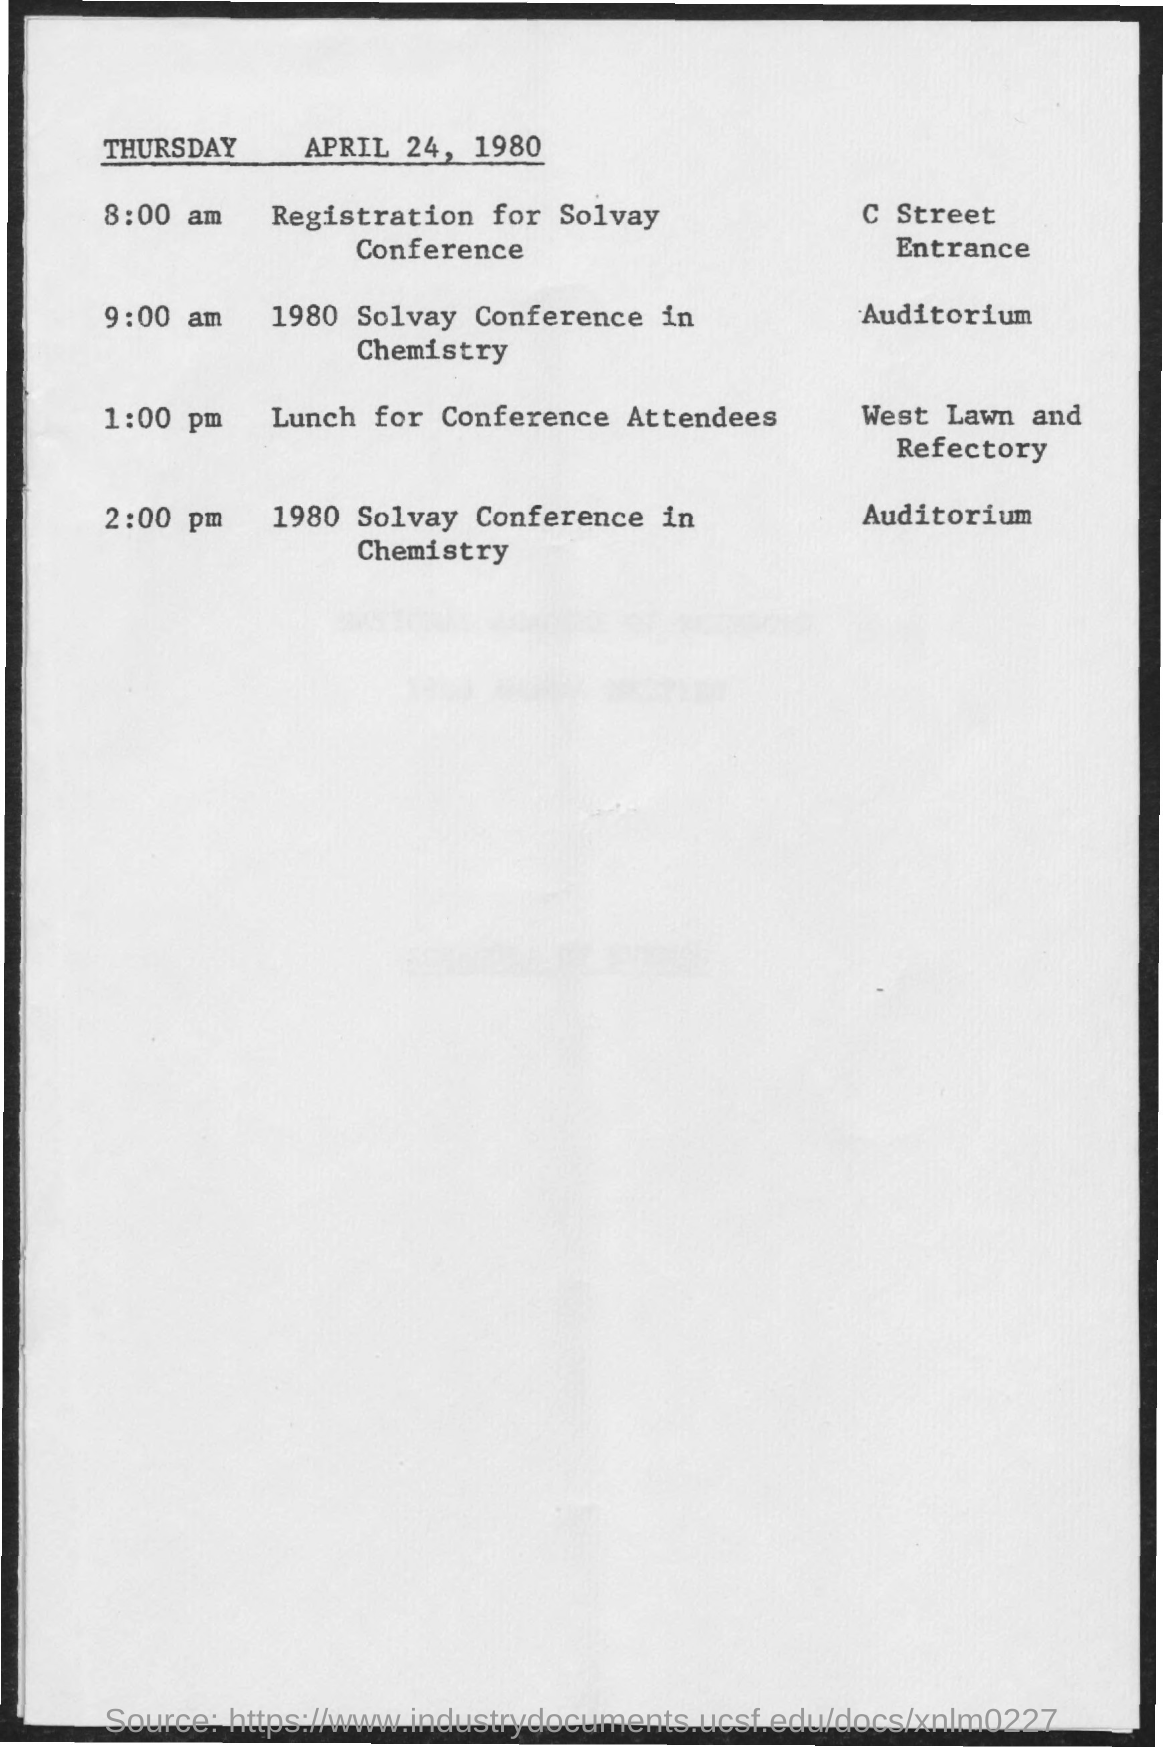What is the schedule at 8:00 am ?
Your answer should be very brief. Registration for Solvay Conference. What is the schedule at the time of 9:00 am ?
Ensure brevity in your answer.  1980 Solvay Conference in Chemistry. What is the scheduled time for lunch for conference attendees ?
Offer a very short reply. 1:00 pm. 